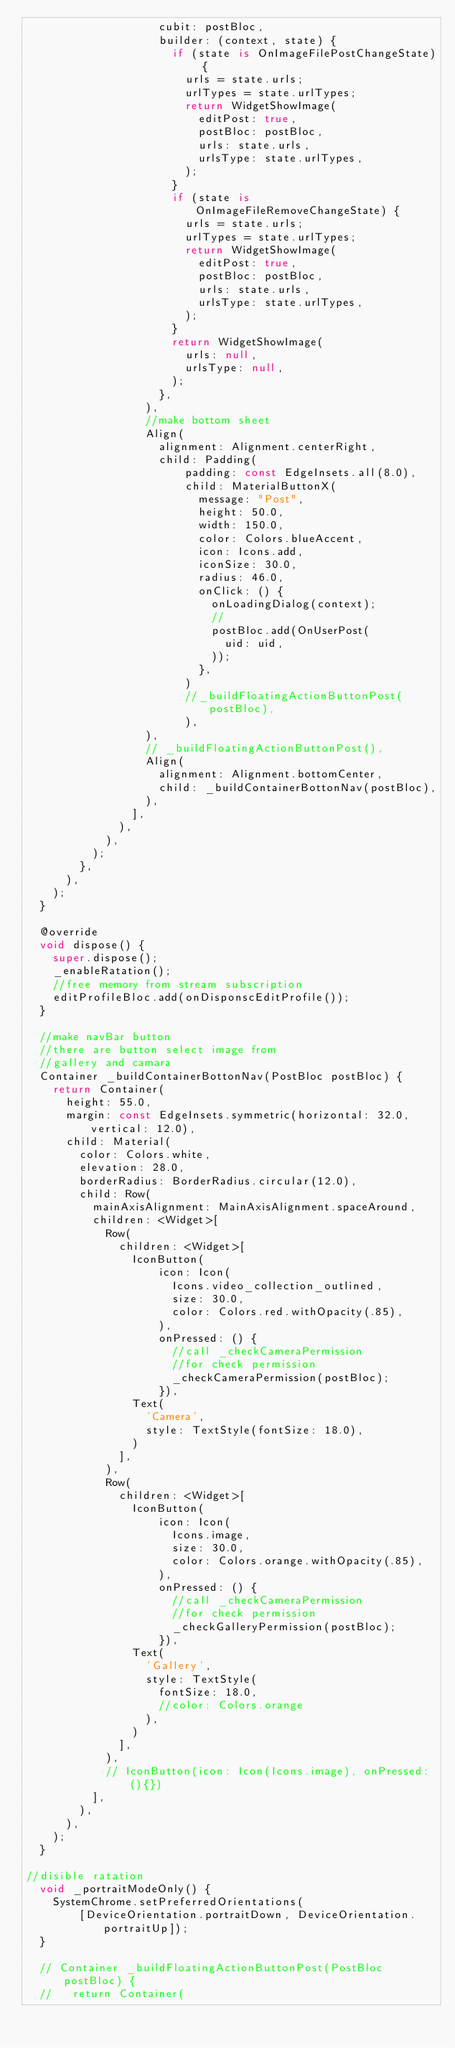<code> <loc_0><loc_0><loc_500><loc_500><_Dart_>                    cubit: postBloc,
                    builder: (context, state) {
                      if (state is OnImageFilePostChangeState) {
                        urls = state.urls;
                        urlTypes = state.urlTypes;
                        return WidgetShowImage(
                          editPost: true,
                          postBloc: postBloc,
                          urls: state.urls,
                          urlsType: state.urlTypes,
                        );
                      }
                      if (state is OnImageFileRemoveChangeState) {
                        urls = state.urls;
                        urlTypes = state.urlTypes;
                        return WidgetShowImage(
                          editPost: true,
                          postBloc: postBloc,
                          urls: state.urls,
                          urlsType: state.urlTypes,
                        );
                      }
                      return WidgetShowImage(
                        urls: null,
                        urlsType: null,
                      );
                    },
                  ),
                  //make bottom sheet
                  Align(
                    alignment: Alignment.centerRight,
                    child: Padding(
                        padding: const EdgeInsets.all(8.0),
                        child: MaterialButtonX(
                          message: "Post",
                          height: 50.0,
                          width: 150.0,
                          color: Colors.blueAccent,
                          icon: Icons.add,
                          iconSize: 30.0,
                          radius: 46.0,
                          onClick: () {
                            onLoadingDialog(context);
                            //
                            postBloc.add(OnUserPost(
                              uid: uid,
                            ));
                          },
                        )
                        //_buildFloatingActionButtonPost(postBloc),
                        ),
                  ),
                  // _buildFloatingActionButtonPost(),
                  Align(
                    alignment: Alignment.bottomCenter,
                    child: _buildContainerBottonNav(postBloc),
                  ),
                ],
              ),
            ),
          );
        },
      ),
    );
  }

  @override
  void dispose() {
    super.dispose();
    _enableRatation();
    //free memory from stream subscription
    editProfileBloc.add(onDisponscEditProfile());
  }

  //make navBar button
  //there are button select image from
  //gallery and camara
  Container _buildContainerBottonNav(PostBloc postBloc) {
    return Container(
      height: 55.0,
      margin: const EdgeInsets.symmetric(horizontal: 32.0, vertical: 12.0),
      child: Material(
        color: Colors.white,
        elevation: 28.0,
        borderRadius: BorderRadius.circular(12.0),
        child: Row(
          mainAxisAlignment: MainAxisAlignment.spaceAround,
          children: <Widget>[
            Row(
              children: <Widget>[
                IconButton(
                    icon: Icon(
                      Icons.video_collection_outlined,
                      size: 30.0,
                      color: Colors.red.withOpacity(.85),
                    ),
                    onPressed: () {
                      //call _checkCameraPermission
                      //for check permission
                      _checkCameraPermission(postBloc);
                    }),
                Text(
                  'Camera',
                  style: TextStyle(fontSize: 18.0),
                )
              ],
            ),
            Row(
              children: <Widget>[
                IconButton(
                    icon: Icon(
                      Icons.image,
                      size: 30.0,
                      color: Colors.orange.withOpacity(.85),
                    ),
                    onPressed: () {
                      //call _checkCameraPermission
                      //for check permission
                      _checkGalleryPermission(postBloc);
                    }),
                Text(
                  'Gallery',
                  style: TextStyle(
                    fontSize: 18.0,
                    //color: Colors.orange
                  ),
                )
              ],
            ),
            // IconButton(icon: Icon(Icons.image), onPressed: (){})
          ],
        ),
      ),
    );
  }

//disible ratation
  void _portraitModeOnly() {
    SystemChrome.setPreferredOrientations(
        [DeviceOrientation.portraitDown, DeviceOrientation.portraitUp]);
  }

  // Container _buildFloatingActionButtonPost(PostBloc postBloc) {
  //   return Container(</code> 